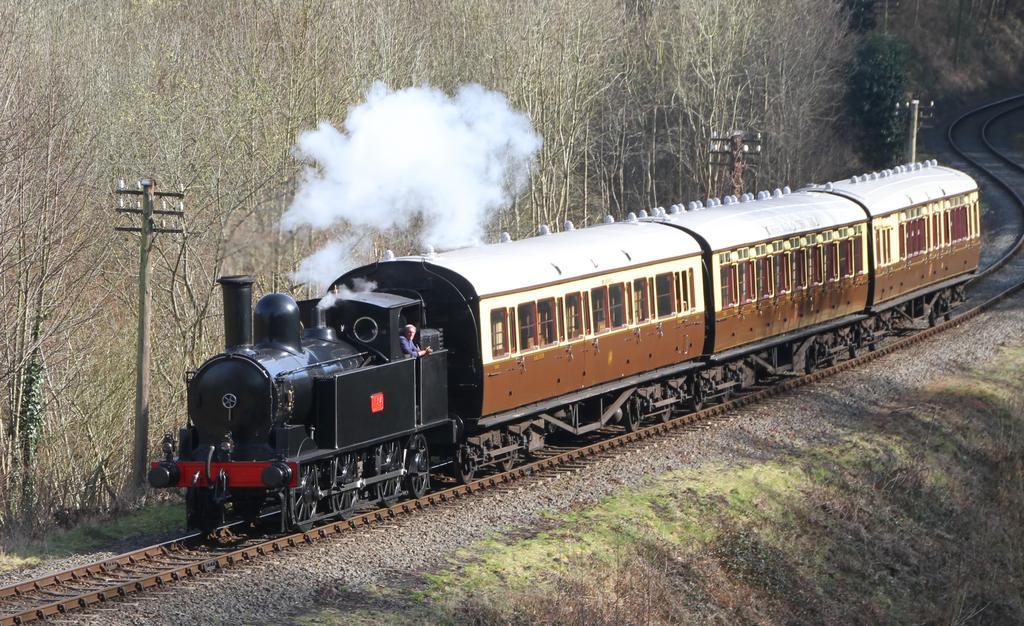Please provide a concise description of this image. Here in this picture we can see a train present on railway track and we can see smoke released by the engine and beside that on either side we can see grass present on the ground and we can also see plants and trees present and we can see electric poles present. 